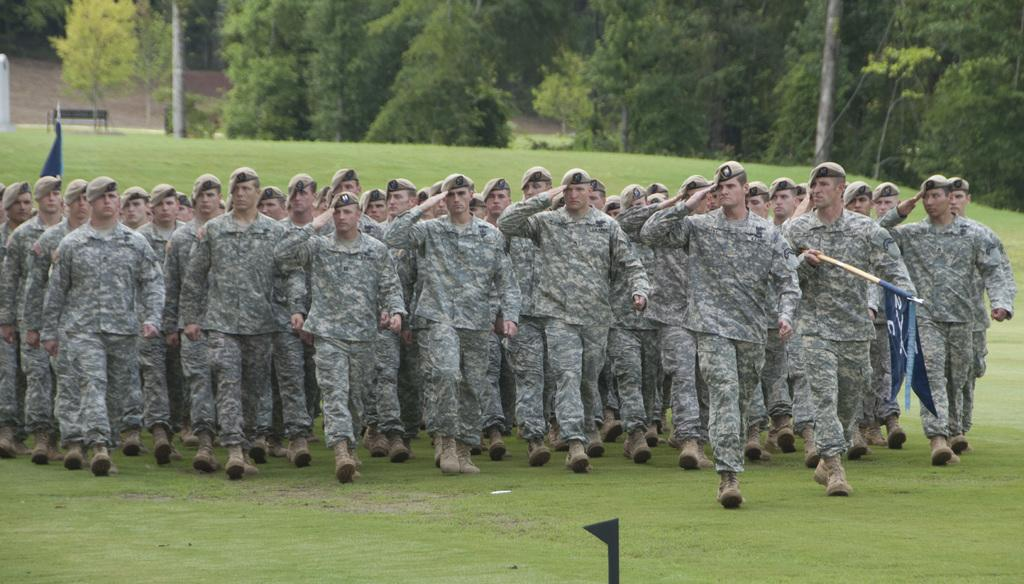How many people are in the image? There are persons in the image. What are the persons wearing? The persons are wearing camouflage dress. What are the persons doing in the image? The persons are walking through a lawn. What can be seen in the background of the image? There are trees in the background of the image. Are the persons in the image slaves working on a plantation? There is no indication in the image that the persons are slaves or working on a plantation. 